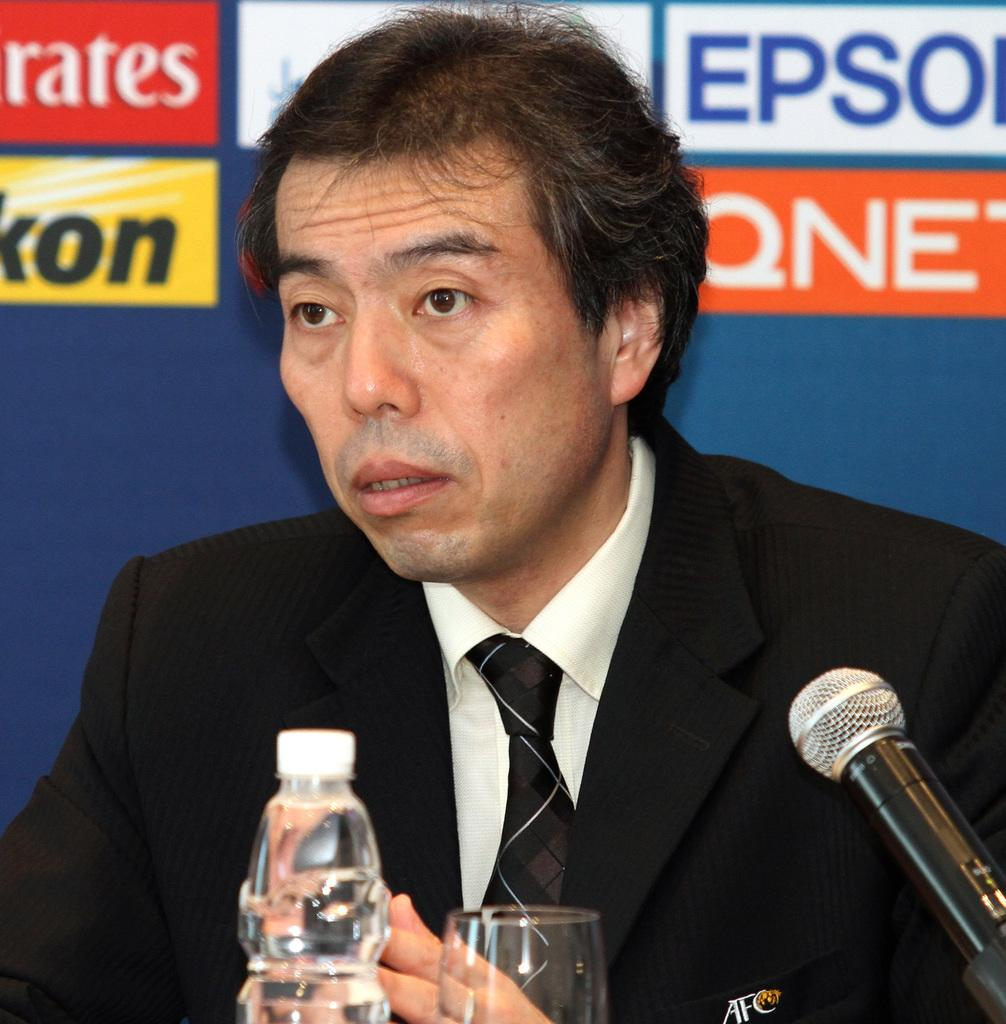Who or what is present in the image? There is a person in the image. What objects can be seen alongside the person? There is a bottle, a glass, and a microphone in the image. What is visible in the background of the image? There is a banner in the background of the image. How many chairs are visible in the image? There are no chairs present in the image. What type of credit card is the person using in the image? There is no credit card or any financial transaction depicted in the image. 